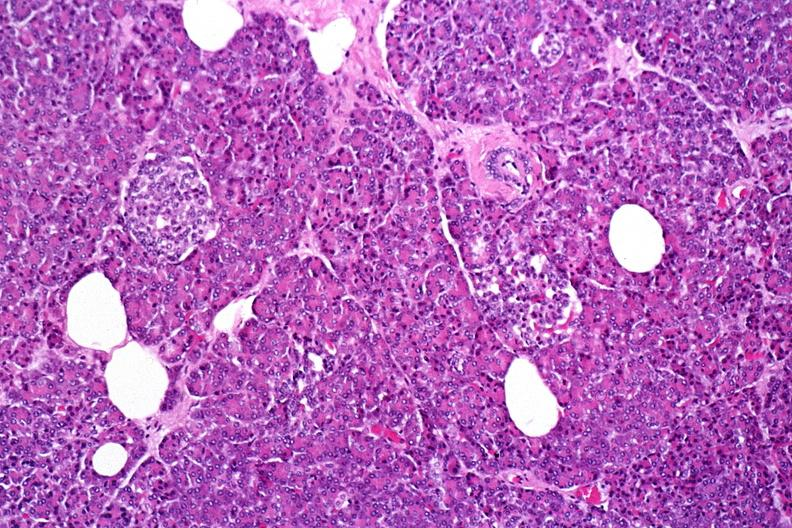what does this image show?
Answer the question using a single word or phrase. Normal pancreas 